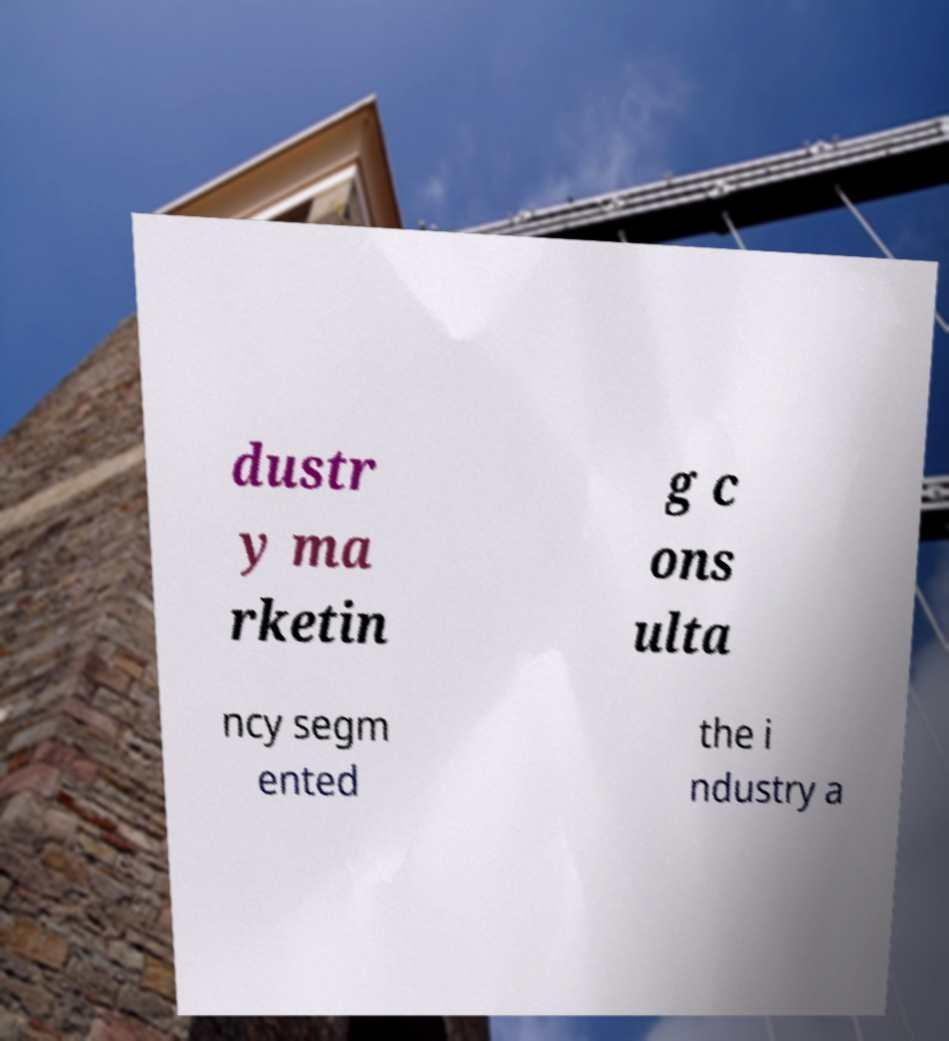Could you extract and type out the text from this image? dustr y ma rketin g c ons ulta ncy segm ented the i ndustry a 